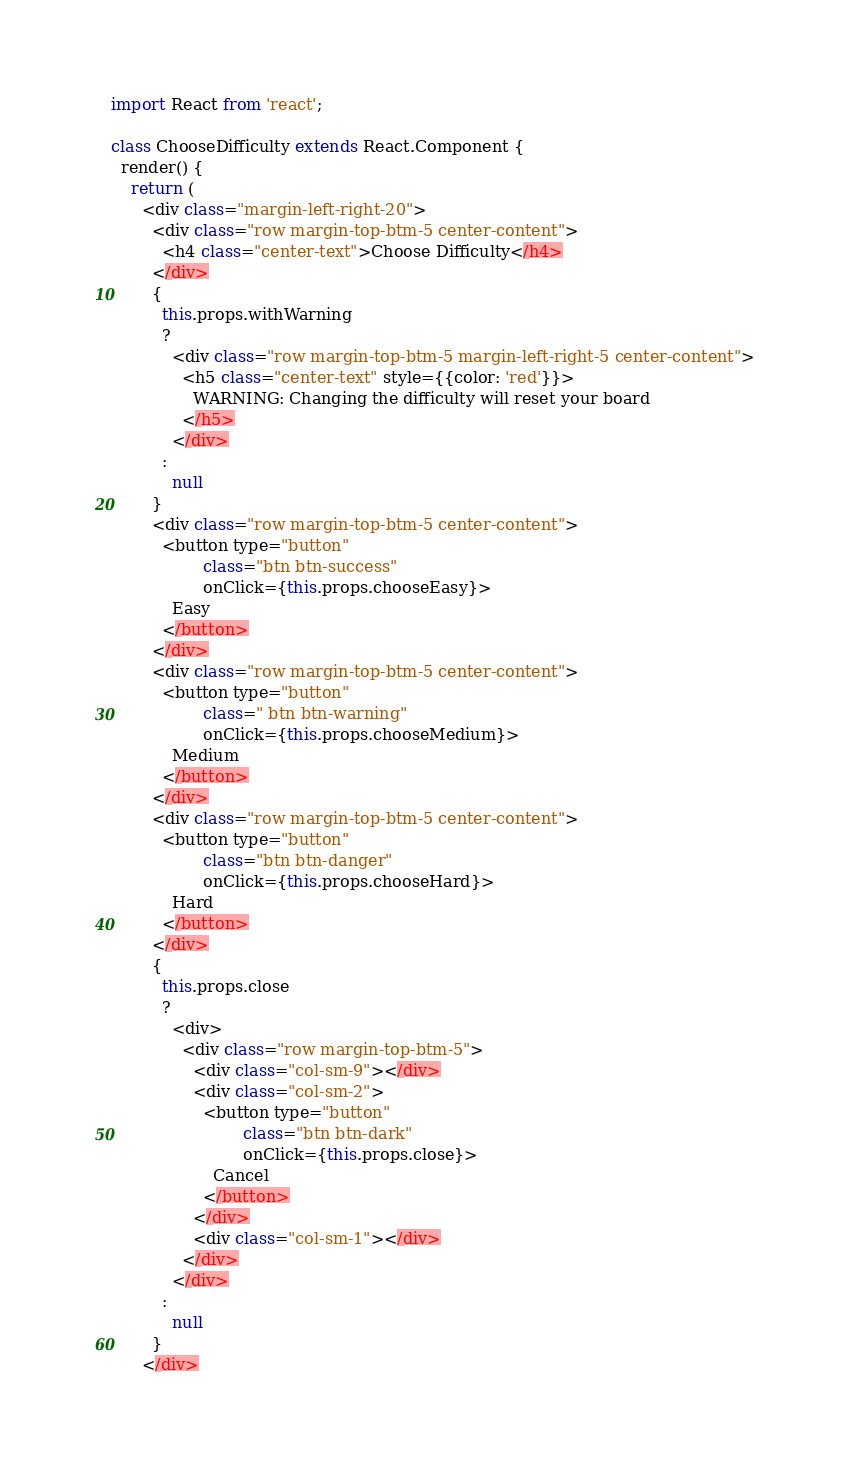<code> <loc_0><loc_0><loc_500><loc_500><_JavaScript_>import React from 'react';

class ChooseDifficulty extends React.Component {
  render() {
    return (
      <div class="margin-left-right-20">
        <div class="row margin-top-btm-5 center-content">
          <h4 class="center-text">Choose Difficulty</h4>
        </div>
        {
          this.props.withWarning 
          ?
            <div class="row margin-top-btm-5 margin-left-right-5 center-content">
              <h5 class="center-text" style={{color: 'red'}}>
                WARNING: Changing the difficulty will reset your board
              </h5>
            </div>
          :
            null
        }
        <div class="row margin-top-btm-5 center-content">
          <button type="button"
                  class="btn btn-success"
                  onClick={this.props.chooseEasy}>
            Easy
          </button>
        </div>
        <div class="row margin-top-btm-5 center-content">
          <button type="button"
                  class=" btn btn-warning"
                  onClick={this.props.chooseMedium}>
            Medium
          </button>
        </div>
        <div class="row margin-top-btm-5 center-content">
          <button type="button"
                  class="btn btn-danger"
                  onClick={this.props.chooseHard}>
            Hard
          </button>
        </div>
        {
          this.props.close 
          ?
            <div>
              <div class="row margin-top-btm-5">
                <div class="col-sm-9"></div>
                <div class="col-sm-2">
                  <button type="button"
                          class="btn btn-dark"
                          onClick={this.props.close}>
                    Cancel
                  </button>
                </div>
                <div class="col-sm-1"></div>
              </div>
            </div>
          :
            null
        }
      </div></code> 